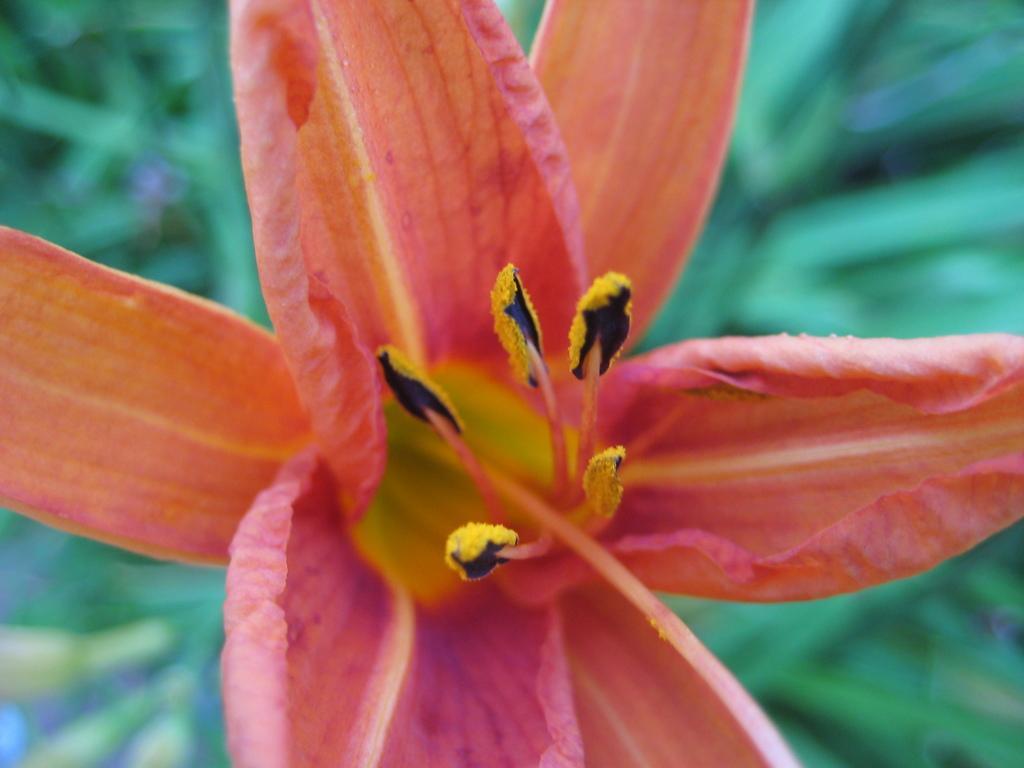Describe this image in one or two sentences. In this picture we can see a flower. In the background of the image it is blue and green. 